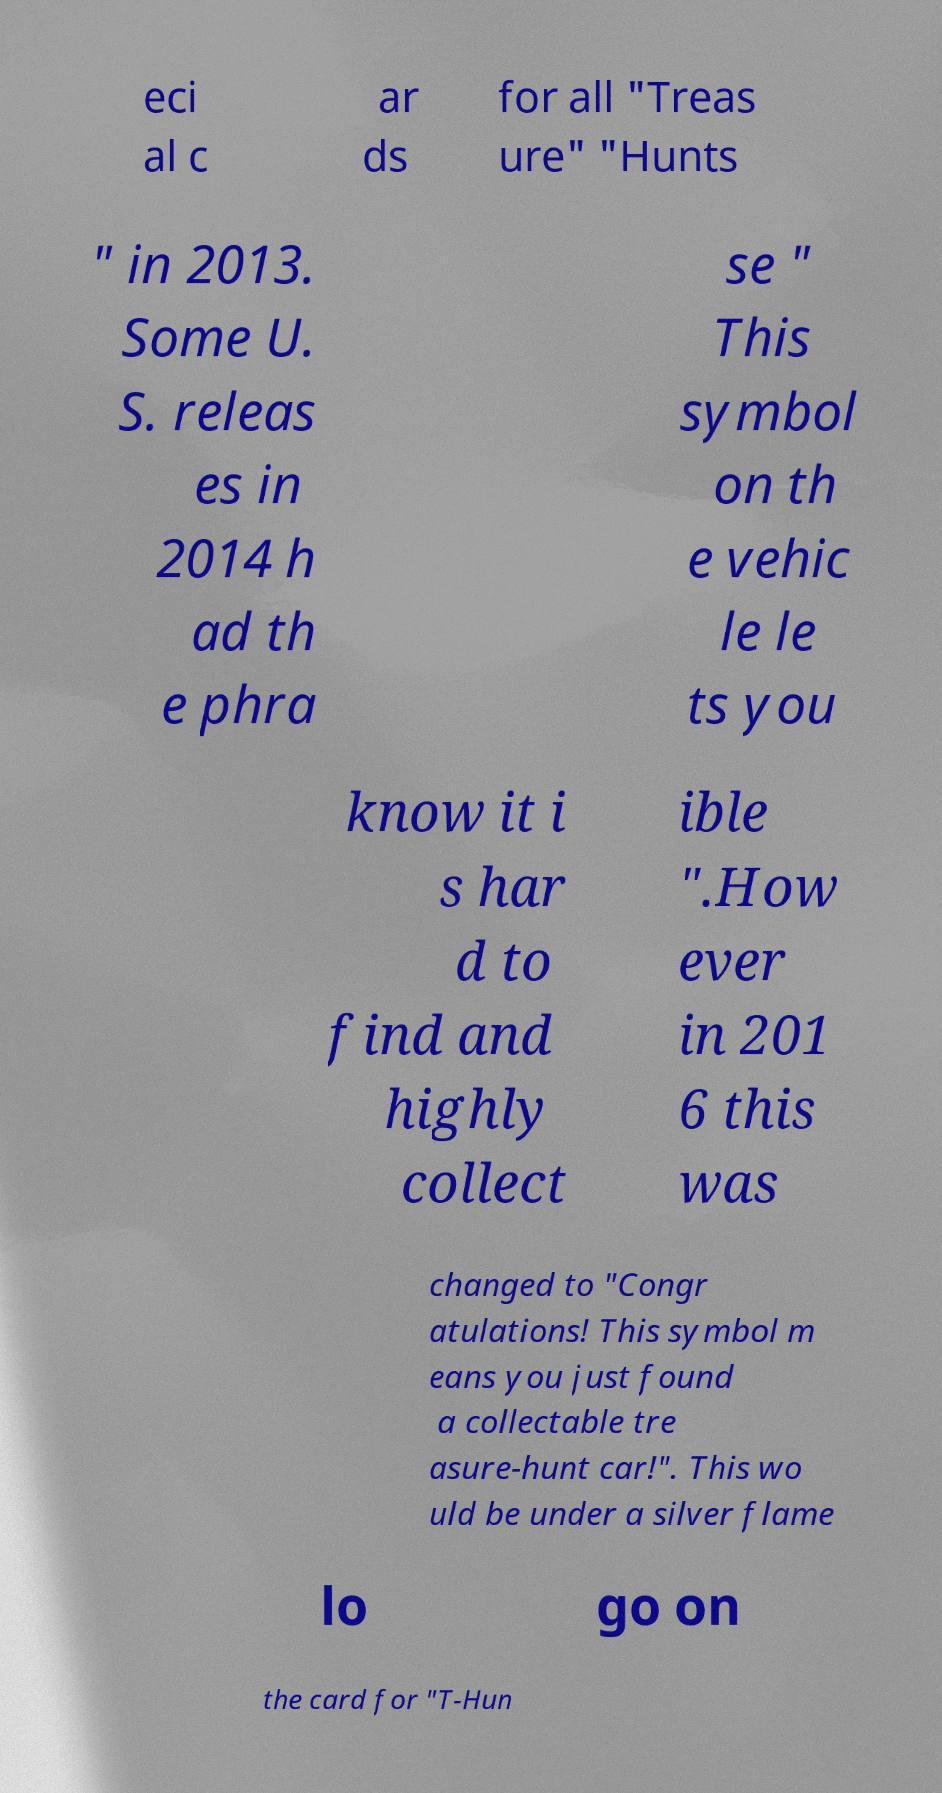Could you extract and type out the text from this image? eci al c ar ds for all "Treas ure" "Hunts " in 2013. Some U. S. releas es in 2014 h ad th e phra se " This symbol on th e vehic le le ts you know it i s har d to find and highly collect ible ".How ever in 201 6 this was changed to "Congr atulations! This symbol m eans you just found a collectable tre asure-hunt car!". This wo uld be under a silver flame lo go on the card for "T-Hun 